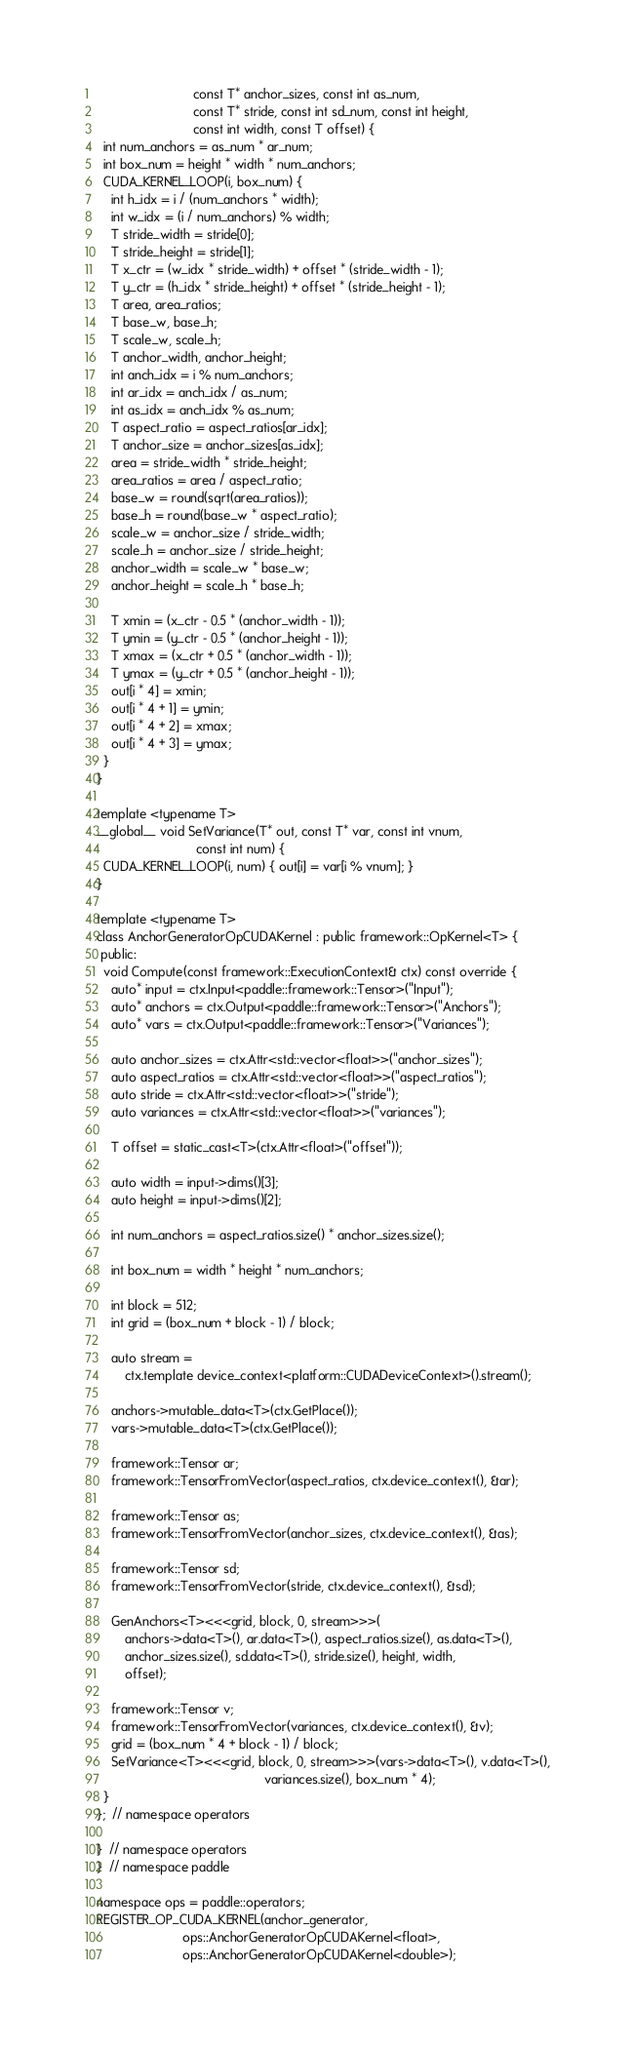<code> <loc_0><loc_0><loc_500><loc_500><_Cuda_>                           const T* anchor_sizes, const int as_num,
                           const T* stride, const int sd_num, const int height,
                           const int width, const T offset) {
  int num_anchors = as_num * ar_num;
  int box_num = height * width * num_anchors;
  CUDA_KERNEL_LOOP(i, box_num) {
    int h_idx = i / (num_anchors * width);
    int w_idx = (i / num_anchors) % width;
    T stride_width = stride[0];
    T stride_height = stride[1];
    T x_ctr = (w_idx * stride_width) + offset * (stride_width - 1);
    T y_ctr = (h_idx * stride_height) + offset * (stride_height - 1);
    T area, area_ratios;
    T base_w, base_h;
    T scale_w, scale_h;
    T anchor_width, anchor_height;
    int anch_idx = i % num_anchors;
    int ar_idx = anch_idx / as_num;
    int as_idx = anch_idx % as_num;
    T aspect_ratio = aspect_ratios[ar_idx];
    T anchor_size = anchor_sizes[as_idx];
    area = stride_width * stride_height;
    area_ratios = area / aspect_ratio;
    base_w = round(sqrt(area_ratios));
    base_h = round(base_w * aspect_ratio);
    scale_w = anchor_size / stride_width;
    scale_h = anchor_size / stride_height;
    anchor_width = scale_w * base_w;
    anchor_height = scale_h * base_h;

    T xmin = (x_ctr - 0.5 * (anchor_width - 1));
    T ymin = (y_ctr - 0.5 * (anchor_height - 1));
    T xmax = (x_ctr + 0.5 * (anchor_width - 1));
    T ymax = (y_ctr + 0.5 * (anchor_height - 1));
    out[i * 4] = xmin;
    out[i * 4 + 1] = ymin;
    out[i * 4 + 2] = xmax;
    out[i * 4 + 3] = ymax;
  }
}

template <typename T>
__global__ void SetVariance(T* out, const T* var, const int vnum,
                            const int num) {
  CUDA_KERNEL_LOOP(i, num) { out[i] = var[i % vnum]; }
}

template <typename T>
class AnchorGeneratorOpCUDAKernel : public framework::OpKernel<T> {
 public:
  void Compute(const framework::ExecutionContext& ctx) const override {
    auto* input = ctx.Input<paddle::framework::Tensor>("Input");
    auto* anchors = ctx.Output<paddle::framework::Tensor>("Anchors");
    auto* vars = ctx.Output<paddle::framework::Tensor>("Variances");

    auto anchor_sizes = ctx.Attr<std::vector<float>>("anchor_sizes");
    auto aspect_ratios = ctx.Attr<std::vector<float>>("aspect_ratios");
    auto stride = ctx.Attr<std::vector<float>>("stride");
    auto variances = ctx.Attr<std::vector<float>>("variances");

    T offset = static_cast<T>(ctx.Attr<float>("offset"));

    auto width = input->dims()[3];
    auto height = input->dims()[2];

    int num_anchors = aspect_ratios.size() * anchor_sizes.size();

    int box_num = width * height * num_anchors;

    int block = 512;
    int grid = (box_num + block - 1) / block;

    auto stream =
        ctx.template device_context<platform::CUDADeviceContext>().stream();

    anchors->mutable_data<T>(ctx.GetPlace());
    vars->mutable_data<T>(ctx.GetPlace());

    framework::Tensor ar;
    framework::TensorFromVector(aspect_ratios, ctx.device_context(), &ar);

    framework::Tensor as;
    framework::TensorFromVector(anchor_sizes, ctx.device_context(), &as);

    framework::Tensor sd;
    framework::TensorFromVector(stride, ctx.device_context(), &sd);

    GenAnchors<T><<<grid, block, 0, stream>>>(
        anchors->data<T>(), ar.data<T>(), aspect_ratios.size(), as.data<T>(),
        anchor_sizes.size(), sd.data<T>(), stride.size(), height, width,
        offset);

    framework::Tensor v;
    framework::TensorFromVector(variances, ctx.device_context(), &v);
    grid = (box_num * 4 + block - 1) / block;
    SetVariance<T><<<grid, block, 0, stream>>>(vars->data<T>(), v.data<T>(),
                                               variances.size(), box_num * 4);
  }
};  // namespace operators

}  // namespace operators
}  // namespace paddle

namespace ops = paddle::operators;
REGISTER_OP_CUDA_KERNEL(anchor_generator,
                        ops::AnchorGeneratorOpCUDAKernel<float>,
                        ops::AnchorGeneratorOpCUDAKernel<double>);
</code> 